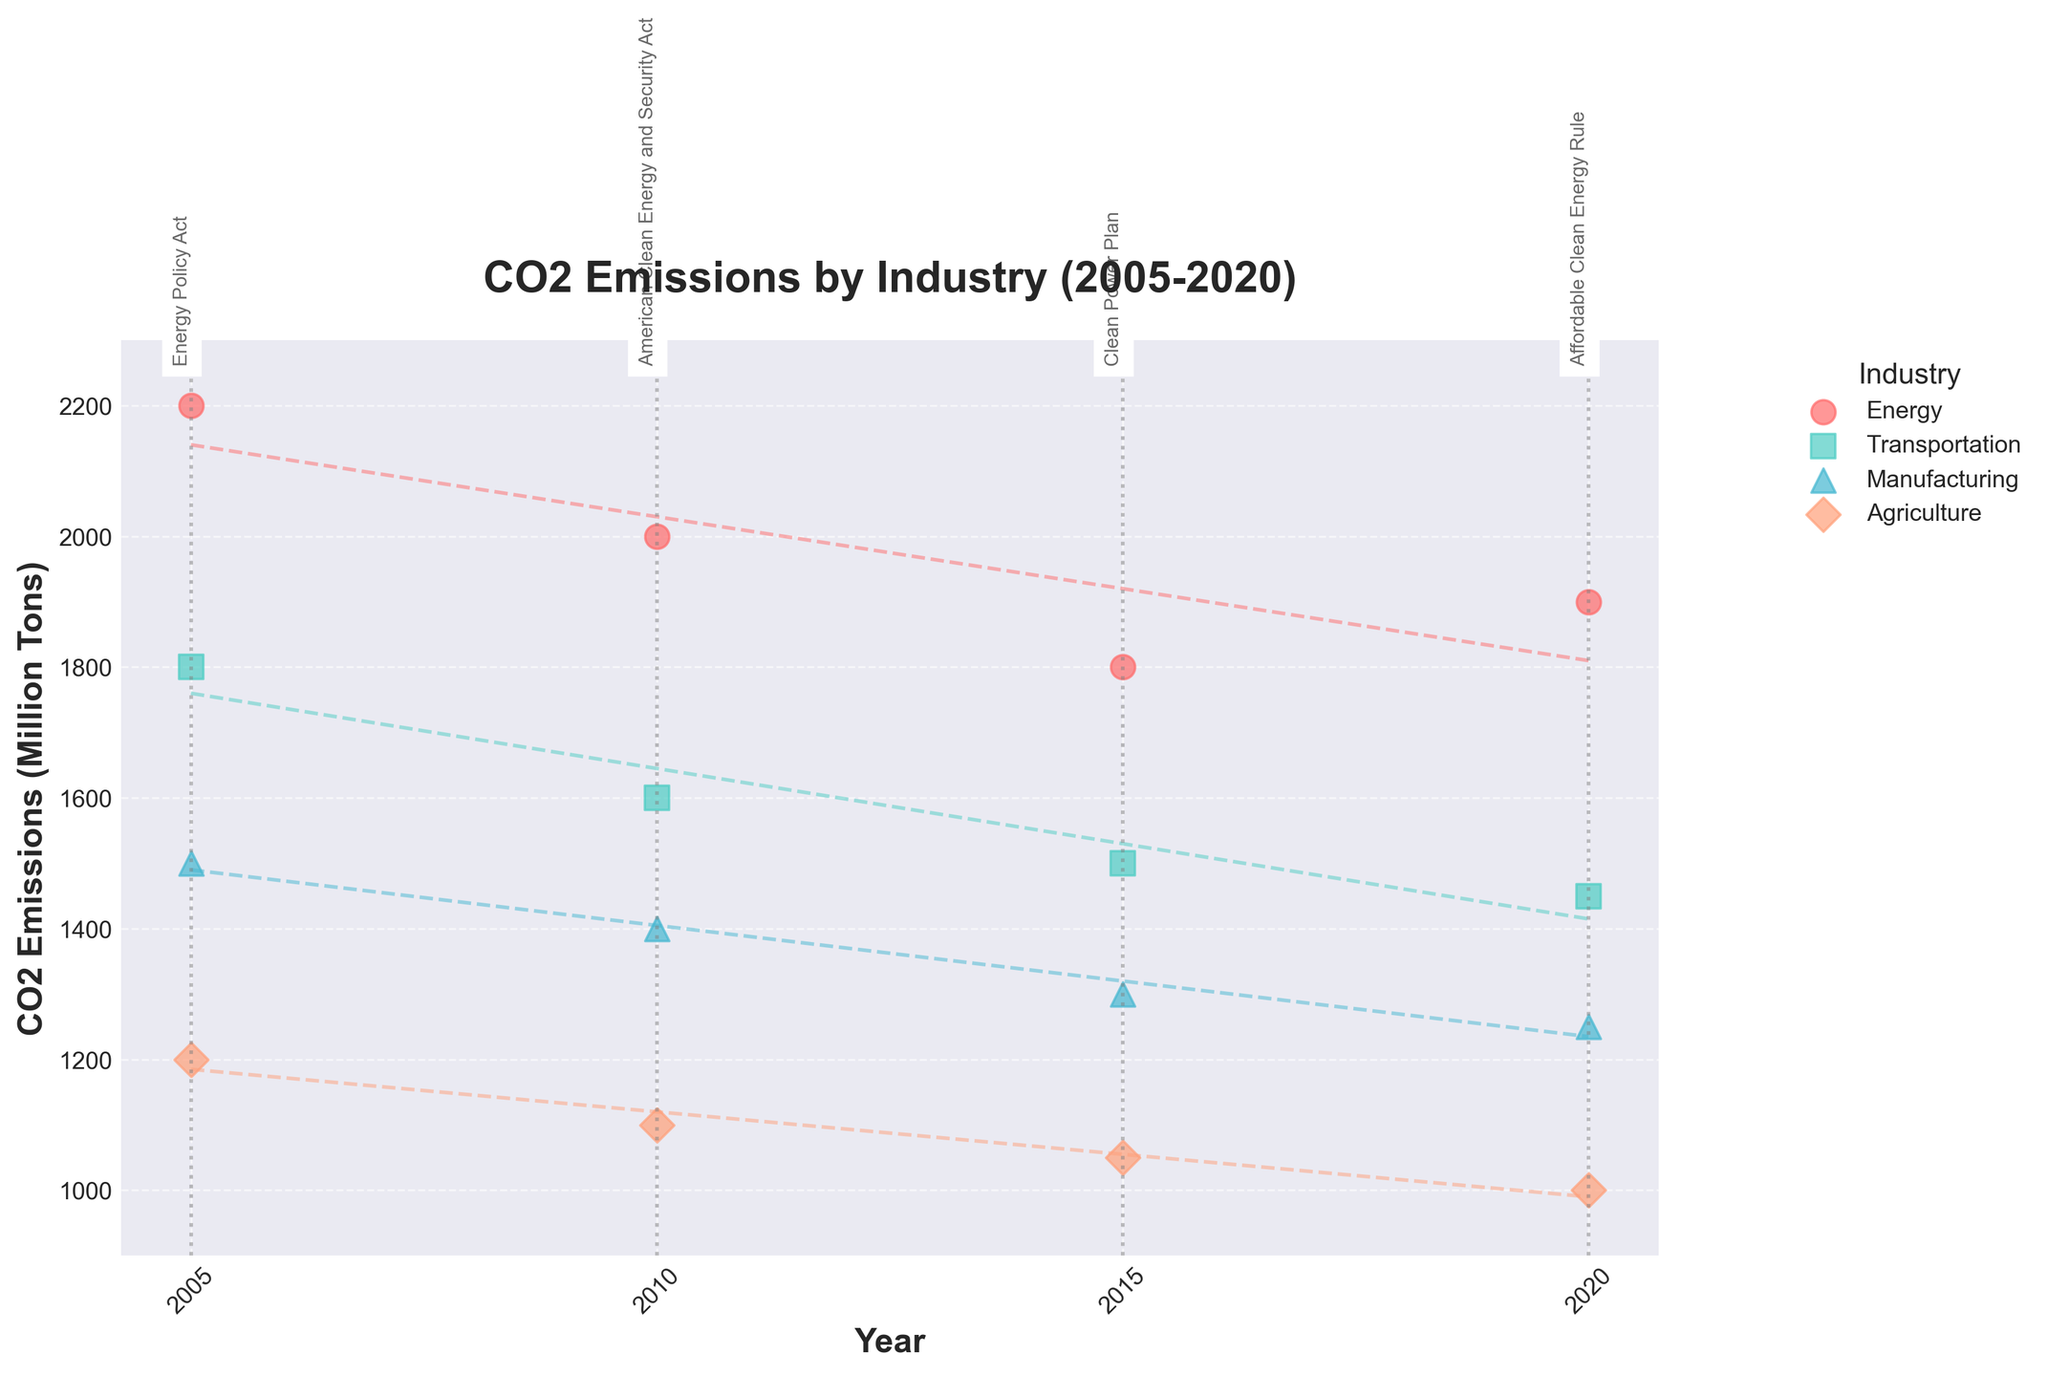What is the title of the figure? The title is displayed at the top of the figure, which reads "CO2 Emissions by Industry (2005-2020)".
Answer: CO2 Emissions by Industry (2005-2020) What industries are represented in the figure? The legend at the top right of the figure indicates the industries represented by different colors and markers. These industries are Energy, Transportation, Manufacturing, and Agriculture.
Answer: Energy, Transportation, Manufacturing, Agriculture What is the trend for CO2 emissions in the Energy industry from 2005 to 2020? The scatter points for the Energy industry follow a downward trend from 2005 to 2015, indicated by decreasing CO2 emissions, with a slight increase in 2020. The trendline also shows a general downward direction.
Answer: Downward from 2005 to 2015, slight increase in 2020 Which federal legislation was implemented in 2015, and what was CO2 emissions for the Transportation industry in that year? The vertical line at 2015 is labeled with 'Clean Power Plan', indicating the federal legislation. The scatter point for the Transportation industry in 2015 shows around 1500 million tons of CO2 emissions.
Answer: Clean Power Plan, 1500 million tons How do CO2 emissions in the Agriculture industry change across the years? CO2 emissions in the Agriculture industry show a consistent decrease from 1200 million tons in 2005 to 1000 million tons in 2020, as indicated by the scatter points and trendline.
Answer: Decrease from 1200 to 1000 million tons Which industry has the highest CO2 emissions in 2020? By comparing the scatter points for each industry in 2020, the Energy industry has the highest CO2 emissions with around 1900 million tons.
Answer: Energy industry What are the emissions differences between the Manufacturing and Transportation industries in 2010? In 2010, Manufacturing has 1400 million tons, and Transportation has 1600 million tons of CO2 emissions. Therefore, the difference is 1600 - 1400 = 200 million tons.
Answer: 200 million tons How many federal legislations are marked in the figure and in which years? There are four vertical dashed lines labeled with federal legislations: Energy Policy Act (2005), American Clean Energy and Security Act (2010), Clean Power Plan (2015), Affordable Clean Energy Rule (2020).
Answer: Four legislations in 2005, 2010, 2015, 2020 